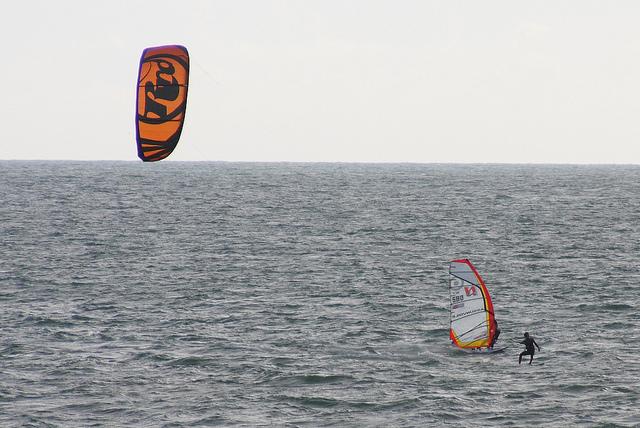Is it sunny out?
Quick response, please. No. What is the largest letter?
Quick response, please. R. Is the kite in the water?
Concise answer only. No. 